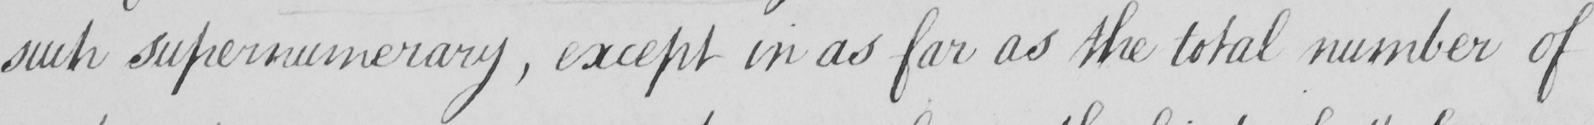Transcribe the text shown in this historical manuscript line. such supernumerary , except in as far as the total number of 